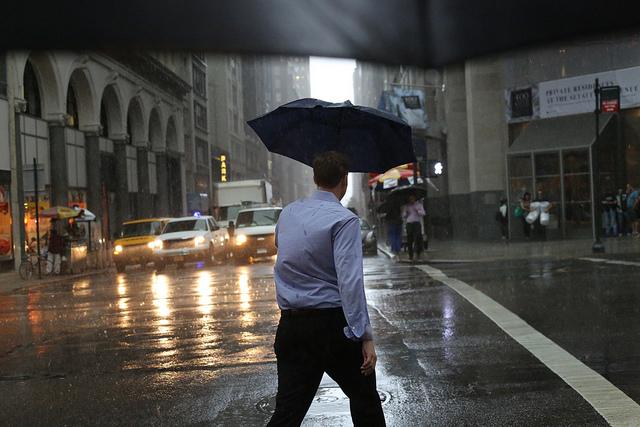What does the man have over his head?
Concise answer only. Umbrella. What kind of weather is taking place?
Write a very short answer. Rain. Are the headlights on?
Short answer required. Yes. 